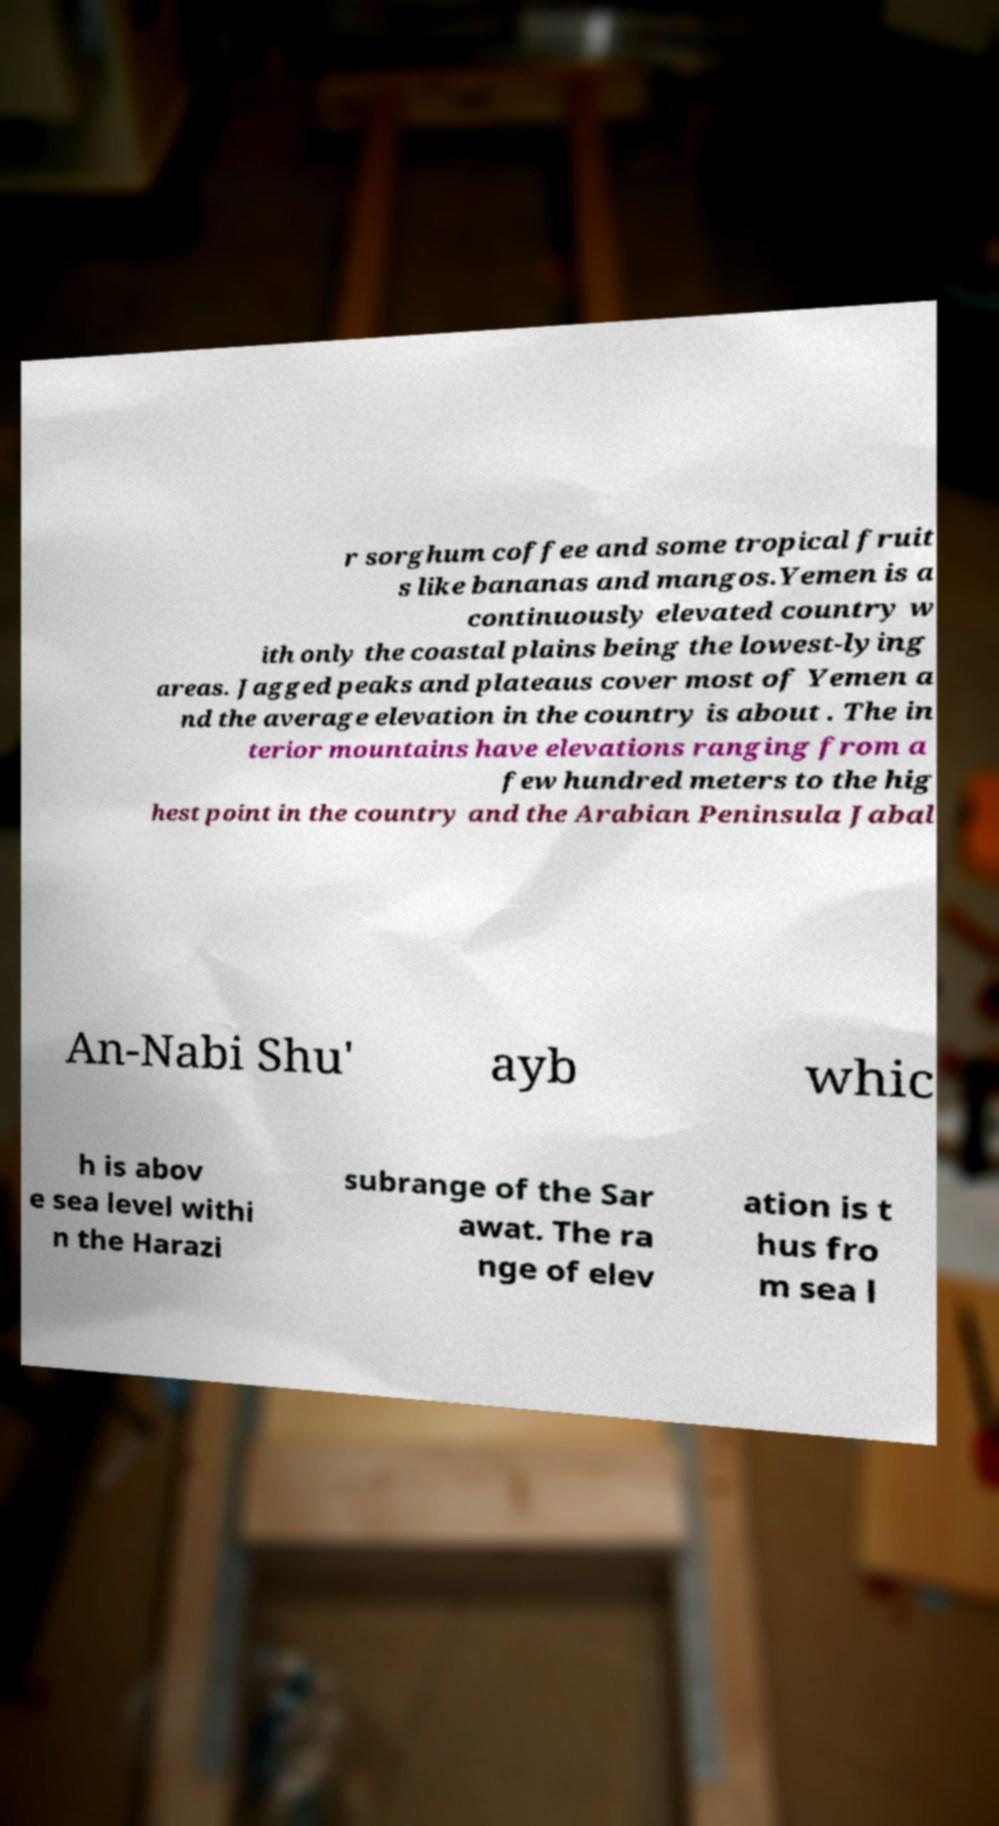Can you accurately transcribe the text from the provided image for me? r sorghum coffee and some tropical fruit s like bananas and mangos.Yemen is a continuously elevated country w ith only the coastal plains being the lowest-lying areas. Jagged peaks and plateaus cover most of Yemen a nd the average elevation in the country is about . The in terior mountains have elevations ranging from a few hundred meters to the hig hest point in the country and the Arabian Peninsula Jabal An-Nabi Shu' ayb whic h is abov e sea level withi n the Harazi subrange of the Sar awat. The ra nge of elev ation is t hus fro m sea l 